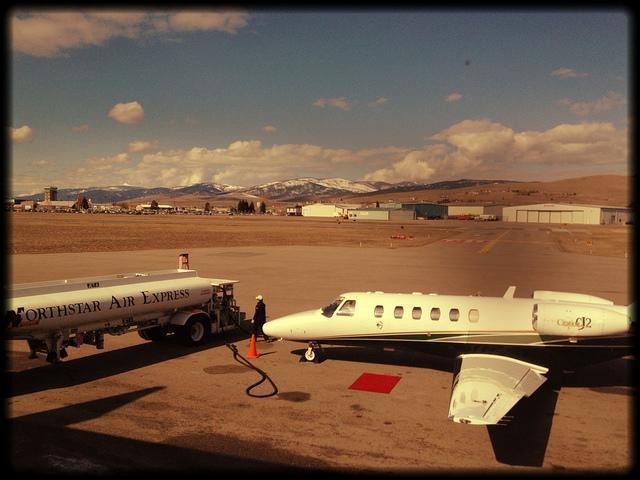What is northstar air express responsible for?
Answer the question by selecting the correct answer among the 4 following choices.
Options: Refueling, cleaning, luggage, maintenance. Refueling. 